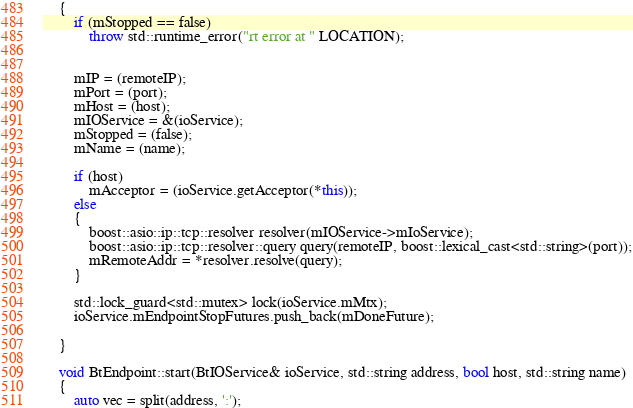<code> <loc_0><loc_0><loc_500><loc_500><_C++_>	{
		if (mStopped == false)
			throw std::runtime_error("rt error at " LOCATION);


		mIP = (remoteIP);
		mPort = (port);
		mHost = (host);
		mIOService = &(ioService);
		mStopped = (false);
		mName = (name);

		if (host)
			mAcceptor = (ioService.getAcceptor(*this));
		else
		{
			boost::asio::ip::tcp::resolver resolver(mIOService->mIoService);
			boost::asio::ip::tcp::resolver::query query(remoteIP, boost::lexical_cast<std::string>(port));
			mRemoteAddr = *resolver.resolve(query);
		}

		std::lock_guard<std::mutex> lock(ioService.mMtx);
		ioService.mEndpointStopFutures.push_back(mDoneFuture);

	}

	void BtEndpoint::start(BtIOService& ioService, std::string address, bool host, std::string name)
	{
		auto vec = split(address, ':');
</code> 